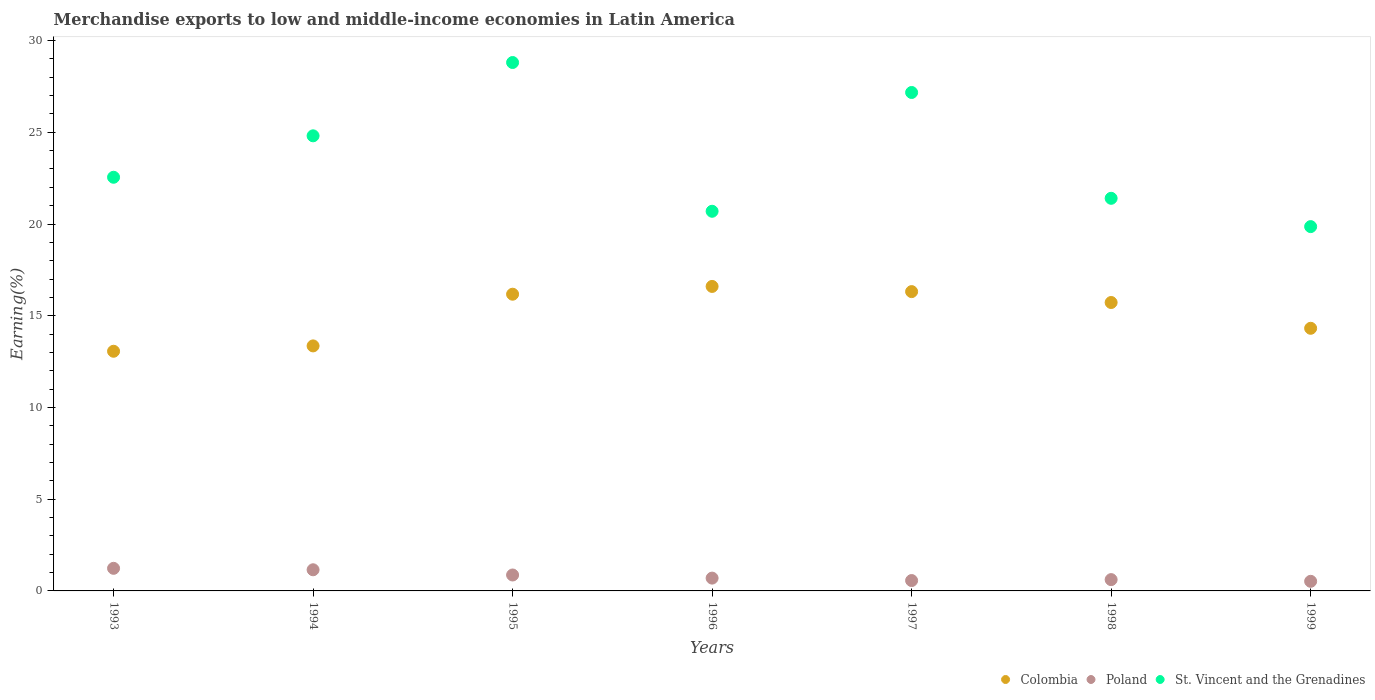Is the number of dotlines equal to the number of legend labels?
Offer a terse response. Yes. What is the percentage of amount earned from merchandise exports in Poland in 1993?
Make the answer very short. 1.23. Across all years, what is the maximum percentage of amount earned from merchandise exports in St. Vincent and the Grenadines?
Provide a short and direct response. 28.8. Across all years, what is the minimum percentage of amount earned from merchandise exports in Poland?
Provide a short and direct response. 0.52. In which year was the percentage of amount earned from merchandise exports in Poland maximum?
Your answer should be very brief. 1993. What is the total percentage of amount earned from merchandise exports in Colombia in the graph?
Your response must be concise. 105.54. What is the difference between the percentage of amount earned from merchandise exports in St. Vincent and the Grenadines in 1994 and that in 1998?
Your answer should be very brief. 3.41. What is the difference between the percentage of amount earned from merchandise exports in Poland in 1993 and the percentage of amount earned from merchandise exports in St. Vincent and the Grenadines in 1998?
Provide a short and direct response. -20.17. What is the average percentage of amount earned from merchandise exports in St. Vincent and the Grenadines per year?
Your answer should be very brief. 23.61. In the year 1993, what is the difference between the percentage of amount earned from merchandise exports in St. Vincent and the Grenadines and percentage of amount earned from merchandise exports in Poland?
Ensure brevity in your answer.  21.32. What is the ratio of the percentage of amount earned from merchandise exports in St. Vincent and the Grenadines in 1998 to that in 1999?
Your answer should be very brief. 1.08. Is the percentage of amount earned from merchandise exports in Colombia in 1994 less than that in 1996?
Your answer should be very brief. Yes. Is the difference between the percentage of amount earned from merchandise exports in St. Vincent and the Grenadines in 1996 and 1998 greater than the difference between the percentage of amount earned from merchandise exports in Poland in 1996 and 1998?
Your answer should be compact. No. What is the difference between the highest and the second highest percentage of amount earned from merchandise exports in Poland?
Your answer should be very brief. 0.08. What is the difference between the highest and the lowest percentage of amount earned from merchandise exports in Colombia?
Provide a succinct answer. 3.53. In how many years, is the percentage of amount earned from merchandise exports in Poland greater than the average percentage of amount earned from merchandise exports in Poland taken over all years?
Give a very brief answer. 3. Is it the case that in every year, the sum of the percentage of amount earned from merchandise exports in Poland and percentage of amount earned from merchandise exports in St. Vincent and the Grenadines  is greater than the percentage of amount earned from merchandise exports in Colombia?
Offer a very short reply. Yes. Is the percentage of amount earned from merchandise exports in St. Vincent and the Grenadines strictly greater than the percentage of amount earned from merchandise exports in Poland over the years?
Ensure brevity in your answer.  Yes. Is the percentage of amount earned from merchandise exports in Poland strictly less than the percentage of amount earned from merchandise exports in Colombia over the years?
Your answer should be compact. Yes. How many years are there in the graph?
Your response must be concise. 7. Are the values on the major ticks of Y-axis written in scientific E-notation?
Make the answer very short. No. Does the graph contain grids?
Give a very brief answer. No. Where does the legend appear in the graph?
Give a very brief answer. Bottom right. What is the title of the graph?
Offer a very short reply. Merchandise exports to low and middle-income economies in Latin America. What is the label or title of the Y-axis?
Provide a short and direct response. Earning(%). What is the Earning(%) of Colombia in 1993?
Provide a succinct answer. 13.06. What is the Earning(%) of Poland in 1993?
Provide a short and direct response. 1.23. What is the Earning(%) of St. Vincent and the Grenadines in 1993?
Your answer should be very brief. 22.55. What is the Earning(%) in Colombia in 1994?
Keep it short and to the point. 13.36. What is the Earning(%) in Poland in 1994?
Your answer should be very brief. 1.15. What is the Earning(%) of St. Vincent and the Grenadines in 1994?
Provide a succinct answer. 24.81. What is the Earning(%) in Colombia in 1995?
Provide a succinct answer. 16.17. What is the Earning(%) of Poland in 1995?
Your answer should be compact. 0.87. What is the Earning(%) of St. Vincent and the Grenadines in 1995?
Make the answer very short. 28.8. What is the Earning(%) in Colombia in 1996?
Keep it short and to the point. 16.6. What is the Earning(%) of Poland in 1996?
Provide a short and direct response. 0.7. What is the Earning(%) of St. Vincent and the Grenadines in 1996?
Your answer should be very brief. 20.69. What is the Earning(%) of Colombia in 1997?
Provide a short and direct response. 16.31. What is the Earning(%) in Poland in 1997?
Provide a succinct answer. 0.57. What is the Earning(%) of St. Vincent and the Grenadines in 1997?
Your response must be concise. 27.17. What is the Earning(%) of Colombia in 1998?
Offer a terse response. 15.72. What is the Earning(%) of Poland in 1998?
Give a very brief answer. 0.62. What is the Earning(%) of St. Vincent and the Grenadines in 1998?
Provide a short and direct response. 21.4. What is the Earning(%) in Colombia in 1999?
Your answer should be compact. 14.32. What is the Earning(%) of Poland in 1999?
Give a very brief answer. 0.52. What is the Earning(%) of St. Vincent and the Grenadines in 1999?
Offer a terse response. 19.86. Across all years, what is the maximum Earning(%) of Colombia?
Ensure brevity in your answer.  16.6. Across all years, what is the maximum Earning(%) in Poland?
Your answer should be very brief. 1.23. Across all years, what is the maximum Earning(%) in St. Vincent and the Grenadines?
Provide a short and direct response. 28.8. Across all years, what is the minimum Earning(%) in Colombia?
Provide a succinct answer. 13.06. Across all years, what is the minimum Earning(%) in Poland?
Provide a short and direct response. 0.52. Across all years, what is the minimum Earning(%) of St. Vincent and the Grenadines?
Provide a succinct answer. 19.86. What is the total Earning(%) of Colombia in the graph?
Ensure brevity in your answer.  105.54. What is the total Earning(%) in Poland in the graph?
Your response must be concise. 5.66. What is the total Earning(%) in St. Vincent and the Grenadines in the graph?
Offer a terse response. 165.28. What is the difference between the Earning(%) in Colombia in 1993 and that in 1994?
Offer a terse response. -0.29. What is the difference between the Earning(%) of Poland in 1993 and that in 1994?
Your answer should be very brief. 0.08. What is the difference between the Earning(%) of St. Vincent and the Grenadines in 1993 and that in 1994?
Offer a terse response. -2.26. What is the difference between the Earning(%) in Colombia in 1993 and that in 1995?
Give a very brief answer. -3.11. What is the difference between the Earning(%) of Poland in 1993 and that in 1995?
Provide a short and direct response. 0.36. What is the difference between the Earning(%) of St. Vincent and the Grenadines in 1993 and that in 1995?
Provide a succinct answer. -6.25. What is the difference between the Earning(%) of Colombia in 1993 and that in 1996?
Keep it short and to the point. -3.53. What is the difference between the Earning(%) in Poland in 1993 and that in 1996?
Your answer should be very brief. 0.53. What is the difference between the Earning(%) in St. Vincent and the Grenadines in 1993 and that in 1996?
Make the answer very short. 1.85. What is the difference between the Earning(%) in Colombia in 1993 and that in 1997?
Your answer should be compact. -3.25. What is the difference between the Earning(%) in Poland in 1993 and that in 1997?
Offer a very short reply. 0.67. What is the difference between the Earning(%) in St. Vincent and the Grenadines in 1993 and that in 1997?
Offer a very short reply. -4.62. What is the difference between the Earning(%) in Colombia in 1993 and that in 1998?
Provide a short and direct response. -2.66. What is the difference between the Earning(%) in Poland in 1993 and that in 1998?
Ensure brevity in your answer.  0.62. What is the difference between the Earning(%) in St. Vincent and the Grenadines in 1993 and that in 1998?
Ensure brevity in your answer.  1.15. What is the difference between the Earning(%) in Colombia in 1993 and that in 1999?
Offer a very short reply. -1.25. What is the difference between the Earning(%) of Poland in 1993 and that in 1999?
Make the answer very short. 0.71. What is the difference between the Earning(%) in St. Vincent and the Grenadines in 1993 and that in 1999?
Make the answer very short. 2.69. What is the difference between the Earning(%) of Colombia in 1994 and that in 1995?
Offer a terse response. -2.82. What is the difference between the Earning(%) in Poland in 1994 and that in 1995?
Provide a succinct answer. 0.28. What is the difference between the Earning(%) in St. Vincent and the Grenadines in 1994 and that in 1995?
Provide a short and direct response. -4. What is the difference between the Earning(%) in Colombia in 1994 and that in 1996?
Your answer should be compact. -3.24. What is the difference between the Earning(%) of Poland in 1994 and that in 1996?
Offer a very short reply. 0.45. What is the difference between the Earning(%) of St. Vincent and the Grenadines in 1994 and that in 1996?
Your answer should be compact. 4.11. What is the difference between the Earning(%) of Colombia in 1994 and that in 1997?
Your answer should be very brief. -2.96. What is the difference between the Earning(%) in Poland in 1994 and that in 1997?
Give a very brief answer. 0.59. What is the difference between the Earning(%) in St. Vincent and the Grenadines in 1994 and that in 1997?
Your answer should be very brief. -2.36. What is the difference between the Earning(%) in Colombia in 1994 and that in 1998?
Give a very brief answer. -2.37. What is the difference between the Earning(%) of Poland in 1994 and that in 1998?
Provide a short and direct response. 0.54. What is the difference between the Earning(%) of St. Vincent and the Grenadines in 1994 and that in 1998?
Give a very brief answer. 3.41. What is the difference between the Earning(%) of Colombia in 1994 and that in 1999?
Ensure brevity in your answer.  -0.96. What is the difference between the Earning(%) in Poland in 1994 and that in 1999?
Make the answer very short. 0.63. What is the difference between the Earning(%) of St. Vincent and the Grenadines in 1994 and that in 1999?
Your answer should be very brief. 4.95. What is the difference between the Earning(%) of Colombia in 1995 and that in 1996?
Give a very brief answer. -0.42. What is the difference between the Earning(%) in Poland in 1995 and that in 1996?
Give a very brief answer. 0.17. What is the difference between the Earning(%) of St. Vincent and the Grenadines in 1995 and that in 1996?
Offer a terse response. 8.11. What is the difference between the Earning(%) of Colombia in 1995 and that in 1997?
Ensure brevity in your answer.  -0.14. What is the difference between the Earning(%) of Poland in 1995 and that in 1997?
Provide a short and direct response. 0.3. What is the difference between the Earning(%) in St. Vincent and the Grenadines in 1995 and that in 1997?
Offer a very short reply. 1.63. What is the difference between the Earning(%) in Colombia in 1995 and that in 1998?
Keep it short and to the point. 0.45. What is the difference between the Earning(%) of Poland in 1995 and that in 1998?
Your answer should be very brief. 0.25. What is the difference between the Earning(%) in St. Vincent and the Grenadines in 1995 and that in 1998?
Offer a very short reply. 7.4. What is the difference between the Earning(%) in Colombia in 1995 and that in 1999?
Your answer should be very brief. 1.86. What is the difference between the Earning(%) of Poland in 1995 and that in 1999?
Your response must be concise. 0.34. What is the difference between the Earning(%) in St. Vincent and the Grenadines in 1995 and that in 1999?
Keep it short and to the point. 8.94. What is the difference between the Earning(%) of Colombia in 1996 and that in 1997?
Keep it short and to the point. 0.28. What is the difference between the Earning(%) of Poland in 1996 and that in 1997?
Ensure brevity in your answer.  0.13. What is the difference between the Earning(%) of St. Vincent and the Grenadines in 1996 and that in 1997?
Keep it short and to the point. -6.47. What is the difference between the Earning(%) in Colombia in 1996 and that in 1998?
Keep it short and to the point. 0.88. What is the difference between the Earning(%) in Poland in 1996 and that in 1998?
Offer a very short reply. 0.08. What is the difference between the Earning(%) of St. Vincent and the Grenadines in 1996 and that in 1998?
Give a very brief answer. -0.71. What is the difference between the Earning(%) of Colombia in 1996 and that in 1999?
Your answer should be very brief. 2.28. What is the difference between the Earning(%) of Poland in 1996 and that in 1999?
Your answer should be compact. 0.17. What is the difference between the Earning(%) in St. Vincent and the Grenadines in 1996 and that in 1999?
Make the answer very short. 0.84. What is the difference between the Earning(%) in Colombia in 1997 and that in 1998?
Keep it short and to the point. 0.59. What is the difference between the Earning(%) of Poland in 1997 and that in 1998?
Offer a very short reply. -0.05. What is the difference between the Earning(%) in St. Vincent and the Grenadines in 1997 and that in 1998?
Keep it short and to the point. 5.77. What is the difference between the Earning(%) of Colombia in 1997 and that in 1999?
Ensure brevity in your answer.  2. What is the difference between the Earning(%) of Poland in 1997 and that in 1999?
Provide a short and direct response. 0.04. What is the difference between the Earning(%) of St. Vincent and the Grenadines in 1997 and that in 1999?
Your answer should be very brief. 7.31. What is the difference between the Earning(%) of Colombia in 1998 and that in 1999?
Your answer should be compact. 1.41. What is the difference between the Earning(%) of Poland in 1998 and that in 1999?
Keep it short and to the point. 0.09. What is the difference between the Earning(%) in St. Vincent and the Grenadines in 1998 and that in 1999?
Your response must be concise. 1.54. What is the difference between the Earning(%) of Colombia in 1993 and the Earning(%) of Poland in 1994?
Your response must be concise. 11.91. What is the difference between the Earning(%) in Colombia in 1993 and the Earning(%) in St. Vincent and the Grenadines in 1994?
Offer a very short reply. -11.74. What is the difference between the Earning(%) of Poland in 1993 and the Earning(%) of St. Vincent and the Grenadines in 1994?
Ensure brevity in your answer.  -23.58. What is the difference between the Earning(%) of Colombia in 1993 and the Earning(%) of Poland in 1995?
Provide a succinct answer. 12.2. What is the difference between the Earning(%) in Colombia in 1993 and the Earning(%) in St. Vincent and the Grenadines in 1995?
Keep it short and to the point. -15.74. What is the difference between the Earning(%) of Poland in 1993 and the Earning(%) of St. Vincent and the Grenadines in 1995?
Give a very brief answer. -27.57. What is the difference between the Earning(%) in Colombia in 1993 and the Earning(%) in Poland in 1996?
Offer a very short reply. 12.37. What is the difference between the Earning(%) of Colombia in 1993 and the Earning(%) of St. Vincent and the Grenadines in 1996?
Offer a very short reply. -7.63. What is the difference between the Earning(%) in Poland in 1993 and the Earning(%) in St. Vincent and the Grenadines in 1996?
Your answer should be compact. -19.46. What is the difference between the Earning(%) of Colombia in 1993 and the Earning(%) of Poland in 1997?
Provide a succinct answer. 12.5. What is the difference between the Earning(%) of Colombia in 1993 and the Earning(%) of St. Vincent and the Grenadines in 1997?
Your response must be concise. -14.11. What is the difference between the Earning(%) of Poland in 1993 and the Earning(%) of St. Vincent and the Grenadines in 1997?
Ensure brevity in your answer.  -25.94. What is the difference between the Earning(%) in Colombia in 1993 and the Earning(%) in Poland in 1998?
Provide a succinct answer. 12.45. What is the difference between the Earning(%) in Colombia in 1993 and the Earning(%) in St. Vincent and the Grenadines in 1998?
Offer a terse response. -8.34. What is the difference between the Earning(%) of Poland in 1993 and the Earning(%) of St. Vincent and the Grenadines in 1998?
Your answer should be compact. -20.17. What is the difference between the Earning(%) of Colombia in 1993 and the Earning(%) of Poland in 1999?
Provide a short and direct response. 12.54. What is the difference between the Earning(%) in Colombia in 1993 and the Earning(%) in St. Vincent and the Grenadines in 1999?
Your answer should be compact. -6.79. What is the difference between the Earning(%) in Poland in 1993 and the Earning(%) in St. Vincent and the Grenadines in 1999?
Offer a terse response. -18.63. What is the difference between the Earning(%) in Colombia in 1994 and the Earning(%) in Poland in 1995?
Your answer should be compact. 12.49. What is the difference between the Earning(%) in Colombia in 1994 and the Earning(%) in St. Vincent and the Grenadines in 1995?
Make the answer very short. -15.45. What is the difference between the Earning(%) in Poland in 1994 and the Earning(%) in St. Vincent and the Grenadines in 1995?
Give a very brief answer. -27.65. What is the difference between the Earning(%) in Colombia in 1994 and the Earning(%) in Poland in 1996?
Provide a succinct answer. 12.66. What is the difference between the Earning(%) of Colombia in 1994 and the Earning(%) of St. Vincent and the Grenadines in 1996?
Provide a short and direct response. -7.34. What is the difference between the Earning(%) of Poland in 1994 and the Earning(%) of St. Vincent and the Grenadines in 1996?
Your response must be concise. -19.54. What is the difference between the Earning(%) of Colombia in 1994 and the Earning(%) of Poland in 1997?
Offer a very short reply. 12.79. What is the difference between the Earning(%) in Colombia in 1994 and the Earning(%) in St. Vincent and the Grenadines in 1997?
Offer a very short reply. -13.81. What is the difference between the Earning(%) of Poland in 1994 and the Earning(%) of St. Vincent and the Grenadines in 1997?
Offer a terse response. -26.02. What is the difference between the Earning(%) of Colombia in 1994 and the Earning(%) of Poland in 1998?
Your response must be concise. 12.74. What is the difference between the Earning(%) of Colombia in 1994 and the Earning(%) of St. Vincent and the Grenadines in 1998?
Provide a succinct answer. -8.05. What is the difference between the Earning(%) in Poland in 1994 and the Earning(%) in St. Vincent and the Grenadines in 1998?
Offer a very short reply. -20.25. What is the difference between the Earning(%) of Colombia in 1994 and the Earning(%) of Poland in 1999?
Make the answer very short. 12.83. What is the difference between the Earning(%) of Colombia in 1994 and the Earning(%) of St. Vincent and the Grenadines in 1999?
Keep it short and to the point. -6.5. What is the difference between the Earning(%) of Poland in 1994 and the Earning(%) of St. Vincent and the Grenadines in 1999?
Give a very brief answer. -18.71. What is the difference between the Earning(%) in Colombia in 1995 and the Earning(%) in Poland in 1996?
Keep it short and to the point. 15.48. What is the difference between the Earning(%) of Colombia in 1995 and the Earning(%) of St. Vincent and the Grenadines in 1996?
Your response must be concise. -4.52. What is the difference between the Earning(%) of Poland in 1995 and the Earning(%) of St. Vincent and the Grenadines in 1996?
Provide a short and direct response. -19.83. What is the difference between the Earning(%) of Colombia in 1995 and the Earning(%) of Poland in 1997?
Ensure brevity in your answer.  15.61. What is the difference between the Earning(%) of Colombia in 1995 and the Earning(%) of St. Vincent and the Grenadines in 1997?
Make the answer very short. -11. What is the difference between the Earning(%) in Poland in 1995 and the Earning(%) in St. Vincent and the Grenadines in 1997?
Ensure brevity in your answer.  -26.3. What is the difference between the Earning(%) in Colombia in 1995 and the Earning(%) in Poland in 1998?
Ensure brevity in your answer.  15.56. What is the difference between the Earning(%) in Colombia in 1995 and the Earning(%) in St. Vincent and the Grenadines in 1998?
Your answer should be compact. -5.23. What is the difference between the Earning(%) of Poland in 1995 and the Earning(%) of St. Vincent and the Grenadines in 1998?
Offer a terse response. -20.53. What is the difference between the Earning(%) in Colombia in 1995 and the Earning(%) in Poland in 1999?
Provide a short and direct response. 15.65. What is the difference between the Earning(%) of Colombia in 1995 and the Earning(%) of St. Vincent and the Grenadines in 1999?
Give a very brief answer. -3.68. What is the difference between the Earning(%) in Poland in 1995 and the Earning(%) in St. Vincent and the Grenadines in 1999?
Offer a very short reply. -18.99. What is the difference between the Earning(%) of Colombia in 1996 and the Earning(%) of Poland in 1997?
Offer a very short reply. 16.03. What is the difference between the Earning(%) in Colombia in 1996 and the Earning(%) in St. Vincent and the Grenadines in 1997?
Give a very brief answer. -10.57. What is the difference between the Earning(%) of Poland in 1996 and the Earning(%) of St. Vincent and the Grenadines in 1997?
Your response must be concise. -26.47. What is the difference between the Earning(%) of Colombia in 1996 and the Earning(%) of Poland in 1998?
Your answer should be compact. 15.98. What is the difference between the Earning(%) of Colombia in 1996 and the Earning(%) of St. Vincent and the Grenadines in 1998?
Offer a terse response. -4.8. What is the difference between the Earning(%) of Poland in 1996 and the Earning(%) of St. Vincent and the Grenadines in 1998?
Provide a succinct answer. -20.7. What is the difference between the Earning(%) in Colombia in 1996 and the Earning(%) in Poland in 1999?
Provide a short and direct response. 16.07. What is the difference between the Earning(%) of Colombia in 1996 and the Earning(%) of St. Vincent and the Grenadines in 1999?
Keep it short and to the point. -3.26. What is the difference between the Earning(%) of Poland in 1996 and the Earning(%) of St. Vincent and the Grenadines in 1999?
Offer a very short reply. -19.16. What is the difference between the Earning(%) in Colombia in 1997 and the Earning(%) in Poland in 1998?
Provide a succinct answer. 15.7. What is the difference between the Earning(%) of Colombia in 1997 and the Earning(%) of St. Vincent and the Grenadines in 1998?
Provide a short and direct response. -5.09. What is the difference between the Earning(%) in Poland in 1997 and the Earning(%) in St. Vincent and the Grenadines in 1998?
Give a very brief answer. -20.84. What is the difference between the Earning(%) in Colombia in 1997 and the Earning(%) in Poland in 1999?
Make the answer very short. 15.79. What is the difference between the Earning(%) in Colombia in 1997 and the Earning(%) in St. Vincent and the Grenadines in 1999?
Your answer should be compact. -3.54. What is the difference between the Earning(%) in Poland in 1997 and the Earning(%) in St. Vincent and the Grenadines in 1999?
Provide a succinct answer. -19.29. What is the difference between the Earning(%) of Colombia in 1998 and the Earning(%) of Poland in 1999?
Provide a succinct answer. 15.2. What is the difference between the Earning(%) of Colombia in 1998 and the Earning(%) of St. Vincent and the Grenadines in 1999?
Provide a short and direct response. -4.14. What is the difference between the Earning(%) of Poland in 1998 and the Earning(%) of St. Vincent and the Grenadines in 1999?
Provide a short and direct response. -19.24. What is the average Earning(%) of Colombia per year?
Your answer should be very brief. 15.08. What is the average Earning(%) of Poland per year?
Ensure brevity in your answer.  0.81. What is the average Earning(%) of St. Vincent and the Grenadines per year?
Provide a short and direct response. 23.61. In the year 1993, what is the difference between the Earning(%) in Colombia and Earning(%) in Poland?
Keep it short and to the point. 11.83. In the year 1993, what is the difference between the Earning(%) in Colombia and Earning(%) in St. Vincent and the Grenadines?
Give a very brief answer. -9.48. In the year 1993, what is the difference between the Earning(%) in Poland and Earning(%) in St. Vincent and the Grenadines?
Your answer should be very brief. -21.32. In the year 1994, what is the difference between the Earning(%) in Colombia and Earning(%) in Poland?
Your response must be concise. 12.2. In the year 1994, what is the difference between the Earning(%) in Colombia and Earning(%) in St. Vincent and the Grenadines?
Offer a very short reply. -11.45. In the year 1994, what is the difference between the Earning(%) of Poland and Earning(%) of St. Vincent and the Grenadines?
Ensure brevity in your answer.  -23.65. In the year 1995, what is the difference between the Earning(%) in Colombia and Earning(%) in Poland?
Give a very brief answer. 15.31. In the year 1995, what is the difference between the Earning(%) of Colombia and Earning(%) of St. Vincent and the Grenadines?
Provide a short and direct response. -12.63. In the year 1995, what is the difference between the Earning(%) of Poland and Earning(%) of St. Vincent and the Grenadines?
Provide a short and direct response. -27.93. In the year 1996, what is the difference between the Earning(%) in Colombia and Earning(%) in Poland?
Offer a very short reply. 15.9. In the year 1996, what is the difference between the Earning(%) in Colombia and Earning(%) in St. Vincent and the Grenadines?
Provide a succinct answer. -4.1. In the year 1996, what is the difference between the Earning(%) of Poland and Earning(%) of St. Vincent and the Grenadines?
Your response must be concise. -20. In the year 1997, what is the difference between the Earning(%) of Colombia and Earning(%) of Poland?
Your response must be concise. 15.75. In the year 1997, what is the difference between the Earning(%) of Colombia and Earning(%) of St. Vincent and the Grenadines?
Provide a short and direct response. -10.85. In the year 1997, what is the difference between the Earning(%) of Poland and Earning(%) of St. Vincent and the Grenadines?
Your answer should be compact. -26.6. In the year 1998, what is the difference between the Earning(%) in Colombia and Earning(%) in Poland?
Provide a succinct answer. 15.1. In the year 1998, what is the difference between the Earning(%) of Colombia and Earning(%) of St. Vincent and the Grenadines?
Your answer should be very brief. -5.68. In the year 1998, what is the difference between the Earning(%) in Poland and Earning(%) in St. Vincent and the Grenadines?
Offer a very short reply. -20.78. In the year 1999, what is the difference between the Earning(%) of Colombia and Earning(%) of Poland?
Offer a terse response. 13.79. In the year 1999, what is the difference between the Earning(%) of Colombia and Earning(%) of St. Vincent and the Grenadines?
Offer a very short reply. -5.54. In the year 1999, what is the difference between the Earning(%) of Poland and Earning(%) of St. Vincent and the Grenadines?
Offer a very short reply. -19.33. What is the ratio of the Earning(%) in Colombia in 1993 to that in 1994?
Your response must be concise. 0.98. What is the ratio of the Earning(%) of Poland in 1993 to that in 1994?
Make the answer very short. 1.07. What is the ratio of the Earning(%) in St. Vincent and the Grenadines in 1993 to that in 1994?
Give a very brief answer. 0.91. What is the ratio of the Earning(%) in Colombia in 1993 to that in 1995?
Keep it short and to the point. 0.81. What is the ratio of the Earning(%) of Poland in 1993 to that in 1995?
Give a very brief answer. 1.42. What is the ratio of the Earning(%) of St. Vincent and the Grenadines in 1993 to that in 1995?
Keep it short and to the point. 0.78. What is the ratio of the Earning(%) of Colombia in 1993 to that in 1996?
Ensure brevity in your answer.  0.79. What is the ratio of the Earning(%) in Poland in 1993 to that in 1996?
Your answer should be very brief. 1.76. What is the ratio of the Earning(%) of St. Vincent and the Grenadines in 1993 to that in 1996?
Provide a short and direct response. 1.09. What is the ratio of the Earning(%) of Colombia in 1993 to that in 1997?
Give a very brief answer. 0.8. What is the ratio of the Earning(%) of Poland in 1993 to that in 1997?
Give a very brief answer. 2.18. What is the ratio of the Earning(%) in St. Vincent and the Grenadines in 1993 to that in 1997?
Provide a succinct answer. 0.83. What is the ratio of the Earning(%) in Colombia in 1993 to that in 1998?
Provide a succinct answer. 0.83. What is the ratio of the Earning(%) in Poland in 1993 to that in 1998?
Keep it short and to the point. 2. What is the ratio of the Earning(%) in St. Vincent and the Grenadines in 1993 to that in 1998?
Offer a very short reply. 1.05. What is the ratio of the Earning(%) in Colombia in 1993 to that in 1999?
Your answer should be very brief. 0.91. What is the ratio of the Earning(%) in Poland in 1993 to that in 1999?
Provide a succinct answer. 2.35. What is the ratio of the Earning(%) of St. Vincent and the Grenadines in 1993 to that in 1999?
Your answer should be very brief. 1.14. What is the ratio of the Earning(%) in Colombia in 1994 to that in 1995?
Keep it short and to the point. 0.83. What is the ratio of the Earning(%) of Poland in 1994 to that in 1995?
Your answer should be compact. 1.33. What is the ratio of the Earning(%) of St. Vincent and the Grenadines in 1994 to that in 1995?
Give a very brief answer. 0.86. What is the ratio of the Earning(%) of Colombia in 1994 to that in 1996?
Ensure brevity in your answer.  0.8. What is the ratio of the Earning(%) of Poland in 1994 to that in 1996?
Your answer should be compact. 1.65. What is the ratio of the Earning(%) of St. Vincent and the Grenadines in 1994 to that in 1996?
Offer a terse response. 1.2. What is the ratio of the Earning(%) in Colombia in 1994 to that in 1997?
Your response must be concise. 0.82. What is the ratio of the Earning(%) of Poland in 1994 to that in 1997?
Offer a terse response. 2.04. What is the ratio of the Earning(%) of St. Vincent and the Grenadines in 1994 to that in 1997?
Keep it short and to the point. 0.91. What is the ratio of the Earning(%) of Colombia in 1994 to that in 1998?
Your answer should be very brief. 0.85. What is the ratio of the Earning(%) of Poland in 1994 to that in 1998?
Offer a very short reply. 1.87. What is the ratio of the Earning(%) in St. Vincent and the Grenadines in 1994 to that in 1998?
Offer a very short reply. 1.16. What is the ratio of the Earning(%) of Colombia in 1994 to that in 1999?
Ensure brevity in your answer.  0.93. What is the ratio of the Earning(%) in Poland in 1994 to that in 1999?
Provide a short and direct response. 2.2. What is the ratio of the Earning(%) in St. Vincent and the Grenadines in 1994 to that in 1999?
Give a very brief answer. 1.25. What is the ratio of the Earning(%) of Colombia in 1995 to that in 1996?
Provide a succinct answer. 0.97. What is the ratio of the Earning(%) in Poland in 1995 to that in 1996?
Make the answer very short. 1.24. What is the ratio of the Earning(%) of St. Vincent and the Grenadines in 1995 to that in 1996?
Your response must be concise. 1.39. What is the ratio of the Earning(%) in Poland in 1995 to that in 1997?
Give a very brief answer. 1.54. What is the ratio of the Earning(%) in St. Vincent and the Grenadines in 1995 to that in 1997?
Your answer should be compact. 1.06. What is the ratio of the Earning(%) in Colombia in 1995 to that in 1998?
Provide a succinct answer. 1.03. What is the ratio of the Earning(%) in Poland in 1995 to that in 1998?
Offer a very short reply. 1.41. What is the ratio of the Earning(%) of St. Vincent and the Grenadines in 1995 to that in 1998?
Your answer should be very brief. 1.35. What is the ratio of the Earning(%) of Colombia in 1995 to that in 1999?
Your answer should be compact. 1.13. What is the ratio of the Earning(%) of Poland in 1995 to that in 1999?
Offer a very short reply. 1.66. What is the ratio of the Earning(%) in St. Vincent and the Grenadines in 1995 to that in 1999?
Make the answer very short. 1.45. What is the ratio of the Earning(%) in Colombia in 1996 to that in 1997?
Your answer should be compact. 1.02. What is the ratio of the Earning(%) in Poland in 1996 to that in 1997?
Ensure brevity in your answer.  1.24. What is the ratio of the Earning(%) of St. Vincent and the Grenadines in 1996 to that in 1997?
Keep it short and to the point. 0.76. What is the ratio of the Earning(%) of Colombia in 1996 to that in 1998?
Provide a short and direct response. 1.06. What is the ratio of the Earning(%) of Poland in 1996 to that in 1998?
Provide a short and direct response. 1.13. What is the ratio of the Earning(%) in Colombia in 1996 to that in 1999?
Provide a succinct answer. 1.16. What is the ratio of the Earning(%) of Poland in 1996 to that in 1999?
Give a very brief answer. 1.33. What is the ratio of the Earning(%) in St. Vincent and the Grenadines in 1996 to that in 1999?
Keep it short and to the point. 1.04. What is the ratio of the Earning(%) in Colombia in 1997 to that in 1998?
Your answer should be very brief. 1.04. What is the ratio of the Earning(%) in Poland in 1997 to that in 1998?
Your answer should be very brief. 0.92. What is the ratio of the Earning(%) in St. Vincent and the Grenadines in 1997 to that in 1998?
Ensure brevity in your answer.  1.27. What is the ratio of the Earning(%) of Colombia in 1997 to that in 1999?
Your response must be concise. 1.14. What is the ratio of the Earning(%) in Poland in 1997 to that in 1999?
Provide a succinct answer. 1.08. What is the ratio of the Earning(%) of St. Vincent and the Grenadines in 1997 to that in 1999?
Keep it short and to the point. 1.37. What is the ratio of the Earning(%) in Colombia in 1998 to that in 1999?
Keep it short and to the point. 1.1. What is the ratio of the Earning(%) in Poland in 1998 to that in 1999?
Make the answer very short. 1.18. What is the ratio of the Earning(%) of St. Vincent and the Grenadines in 1998 to that in 1999?
Offer a terse response. 1.08. What is the difference between the highest and the second highest Earning(%) of Colombia?
Make the answer very short. 0.28. What is the difference between the highest and the second highest Earning(%) of Poland?
Give a very brief answer. 0.08. What is the difference between the highest and the second highest Earning(%) in St. Vincent and the Grenadines?
Provide a succinct answer. 1.63. What is the difference between the highest and the lowest Earning(%) in Colombia?
Keep it short and to the point. 3.53. What is the difference between the highest and the lowest Earning(%) in Poland?
Your answer should be very brief. 0.71. What is the difference between the highest and the lowest Earning(%) of St. Vincent and the Grenadines?
Your response must be concise. 8.94. 